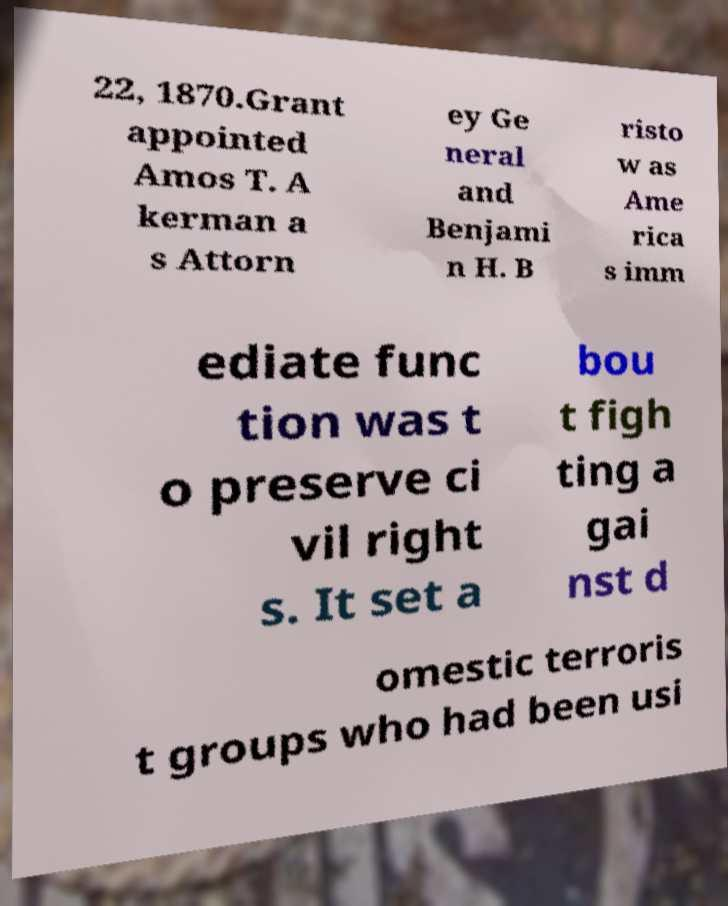Can you read and provide the text displayed in the image?This photo seems to have some interesting text. Can you extract and type it out for me? 22, 1870.Grant appointed Amos T. A kerman a s Attorn ey Ge neral and Benjami n H. B risto w as Ame rica s imm ediate func tion was t o preserve ci vil right s. It set a bou t figh ting a gai nst d omestic terroris t groups who had been usi 